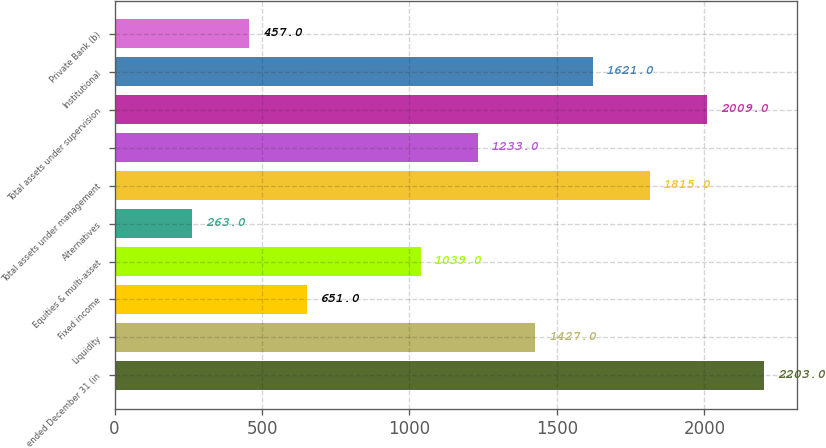Convert chart to OTSL. <chart><loc_0><loc_0><loc_500><loc_500><bar_chart><fcel>ended December 31 (in<fcel>Liquidity<fcel>Fixed income<fcel>Equities & multi-asset<fcel>Alternatives<fcel>Total assets under management<fcel>Unnamed: 6<fcel>Total assets under supervision<fcel>Institutional<fcel>Private Bank (b)<nl><fcel>2203<fcel>1427<fcel>651<fcel>1039<fcel>263<fcel>1815<fcel>1233<fcel>2009<fcel>1621<fcel>457<nl></chart> 